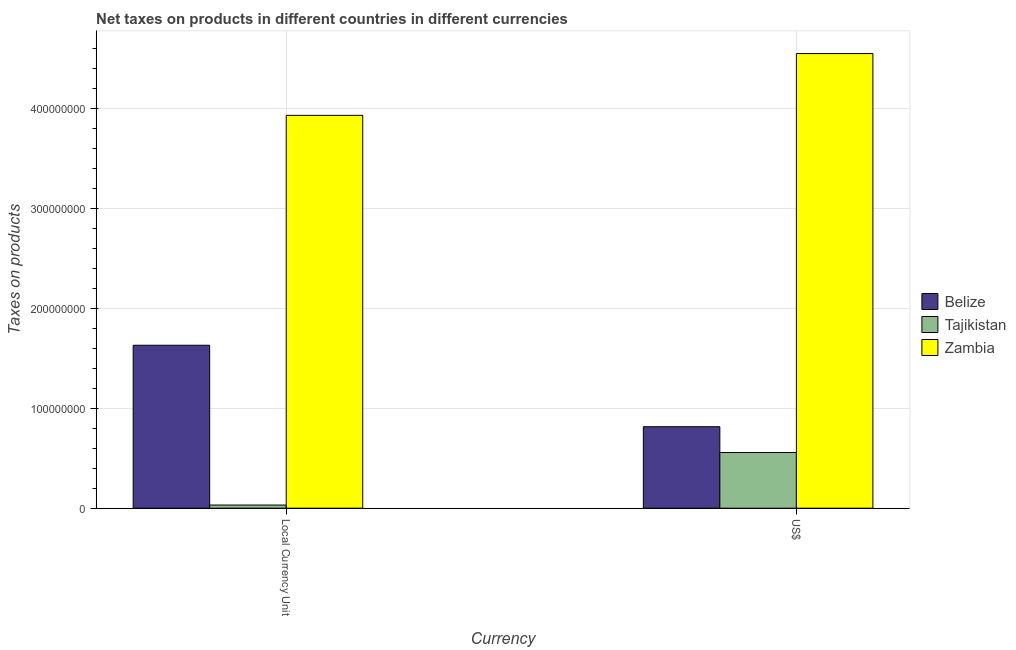How many different coloured bars are there?
Your response must be concise. 3. Are the number of bars per tick equal to the number of legend labels?
Keep it short and to the point. Yes. Are the number of bars on each tick of the X-axis equal?
Your answer should be very brief. Yes. How many bars are there on the 1st tick from the left?
Make the answer very short. 3. What is the label of the 1st group of bars from the left?
Provide a succinct answer. Local Currency Unit. What is the net taxes in constant 2005 us$ in Zambia?
Make the answer very short. 3.93e+08. Across all countries, what is the maximum net taxes in us$?
Your answer should be very brief. 4.55e+08. Across all countries, what is the minimum net taxes in constant 2005 us$?
Keep it short and to the point. 3.16e+06. In which country was the net taxes in us$ maximum?
Your answer should be very brief. Zambia. In which country was the net taxes in us$ minimum?
Ensure brevity in your answer.  Tajikistan. What is the total net taxes in us$ in the graph?
Offer a very short reply. 5.92e+08. What is the difference between the net taxes in constant 2005 us$ in Belize and that in Tajikistan?
Give a very brief answer. 1.60e+08. What is the difference between the net taxes in us$ in Tajikistan and the net taxes in constant 2005 us$ in Zambia?
Provide a succinct answer. -3.37e+08. What is the average net taxes in constant 2005 us$ per country?
Make the answer very short. 1.86e+08. What is the difference between the net taxes in constant 2005 us$ and net taxes in us$ in Zambia?
Your answer should be very brief. -6.18e+07. What is the ratio of the net taxes in constant 2005 us$ in Tajikistan to that in Belize?
Offer a terse response. 0.02. Is the net taxes in constant 2005 us$ in Belize less than that in Zambia?
Your response must be concise. Yes. What does the 2nd bar from the left in Local Currency Unit represents?
Offer a very short reply. Tajikistan. What does the 2nd bar from the right in Local Currency Unit represents?
Make the answer very short. Tajikistan. How many bars are there?
Provide a short and direct response. 6. How many countries are there in the graph?
Provide a short and direct response. 3. What is the difference between two consecutive major ticks on the Y-axis?
Provide a succinct answer. 1.00e+08. Are the values on the major ticks of Y-axis written in scientific E-notation?
Give a very brief answer. No. Does the graph contain grids?
Offer a terse response. Yes. Where does the legend appear in the graph?
Ensure brevity in your answer.  Center right. How many legend labels are there?
Your response must be concise. 3. How are the legend labels stacked?
Make the answer very short. Vertical. What is the title of the graph?
Give a very brief answer. Net taxes on products in different countries in different currencies. Does "Malaysia" appear as one of the legend labels in the graph?
Your answer should be very brief. No. What is the label or title of the X-axis?
Provide a short and direct response. Currency. What is the label or title of the Y-axis?
Your response must be concise. Taxes on products. What is the Taxes on products of Belize in Local Currency Unit?
Provide a succinct answer. 1.63e+08. What is the Taxes on products of Tajikistan in Local Currency Unit?
Offer a very short reply. 3.16e+06. What is the Taxes on products of Zambia in Local Currency Unit?
Offer a terse response. 3.93e+08. What is the Taxes on products of Belize in US$?
Give a very brief answer. 8.15e+07. What is the Taxes on products in Tajikistan in US$?
Your response must be concise. 5.57e+07. What is the Taxes on products of Zambia in US$?
Provide a succinct answer. 4.55e+08. Across all Currency, what is the maximum Taxes on products in Belize?
Keep it short and to the point. 1.63e+08. Across all Currency, what is the maximum Taxes on products in Tajikistan?
Make the answer very short. 5.57e+07. Across all Currency, what is the maximum Taxes on products in Zambia?
Keep it short and to the point. 4.55e+08. Across all Currency, what is the minimum Taxes on products in Belize?
Your response must be concise. 8.15e+07. Across all Currency, what is the minimum Taxes on products of Tajikistan?
Provide a short and direct response. 3.16e+06. Across all Currency, what is the minimum Taxes on products of Zambia?
Provide a short and direct response. 3.93e+08. What is the total Taxes on products in Belize in the graph?
Provide a succinct answer. 2.44e+08. What is the total Taxes on products of Tajikistan in the graph?
Offer a very short reply. 5.89e+07. What is the total Taxes on products of Zambia in the graph?
Offer a very short reply. 8.48e+08. What is the difference between the Taxes on products in Belize in Local Currency Unit and that in US$?
Provide a succinct answer. 8.15e+07. What is the difference between the Taxes on products of Tajikistan in Local Currency Unit and that in US$?
Give a very brief answer. -5.25e+07. What is the difference between the Taxes on products in Zambia in Local Currency Unit and that in US$?
Your answer should be compact. -6.18e+07. What is the difference between the Taxes on products of Belize in Local Currency Unit and the Taxes on products of Tajikistan in US$?
Offer a terse response. 1.07e+08. What is the difference between the Taxes on products of Belize in Local Currency Unit and the Taxes on products of Zambia in US$?
Give a very brief answer. -2.92e+08. What is the difference between the Taxes on products of Tajikistan in Local Currency Unit and the Taxes on products of Zambia in US$?
Offer a very short reply. -4.52e+08. What is the average Taxes on products in Belize per Currency?
Your answer should be compact. 1.22e+08. What is the average Taxes on products of Tajikistan per Currency?
Your answer should be very brief. 2.94e+07. What is the average Taxes on products of Zambia per Currency?
Make the answer very short. 4.24e+08. What is the difference between the Taxes on products in Belize and Taxes on products in Tajikistan in Local Currency Unit?
Keep it short and to the point. 1.60e+08. What is the difference between the Taxes on products of Belize and Taxes on products of Zambia in Local Currency Unit?
Offer a terse response. -2.30e+08. What is the difference between the Taxes on products of Tajikistan and Taxes on products of Zambia in Local Currency Unit?
Offer a terse response. -3.90e+08. What is the difference between the Taxes on products of Belize and Taxes on products of Tajikistan in US$?
Ensure brevity in your answer.  2.58e+07. What is the difference between the Taxes on products of Belize and Taxes on products of Zambia in US$?
Your answer should be very brief. -3.73e+08. What is the difference between the Taxes on products in Tajikistan and Taxes on products in Zambia in US$?
Your response must be concise. -3.99e+08. What is the ratio of the Taxes on products in Belize in Local Currency Unit to that in US$?
Ensure brevity in your answer.  2. What is the ratio of the Taxes on products in Tajikistan in Local Currency Unit to that in US$?
Offer a very short reply. 0.06. What is the ratio of the Taxes on products in Zambia in Local Currency Unit to that in US$?
Make the answer very short. 0.86. What is the difference between the highest and the second highest Taxes on products in Belize?
Offer a very short reply. 8.15e+07. What is the difference between the highest and the second highest Taxes on products in Tajikistan?
Give a very brief answer. 5.25e+07. What is the difference between the highest and the second highest Taxes on products of Zambia?
Keep it short and to the point. 6.18e+07. What is the difference between the highest and the lowest Taxes on products in Belize?
Your response must be concise. 8.15e+07. What is the difference between the highest and the lowest Taxes on products in Tajikistan?
Offer a terse response. 5.25e+07. What is the difference between the highest and the lowest Taxes on products of Zambia?
Offer a terse response. 6.18e+07. 